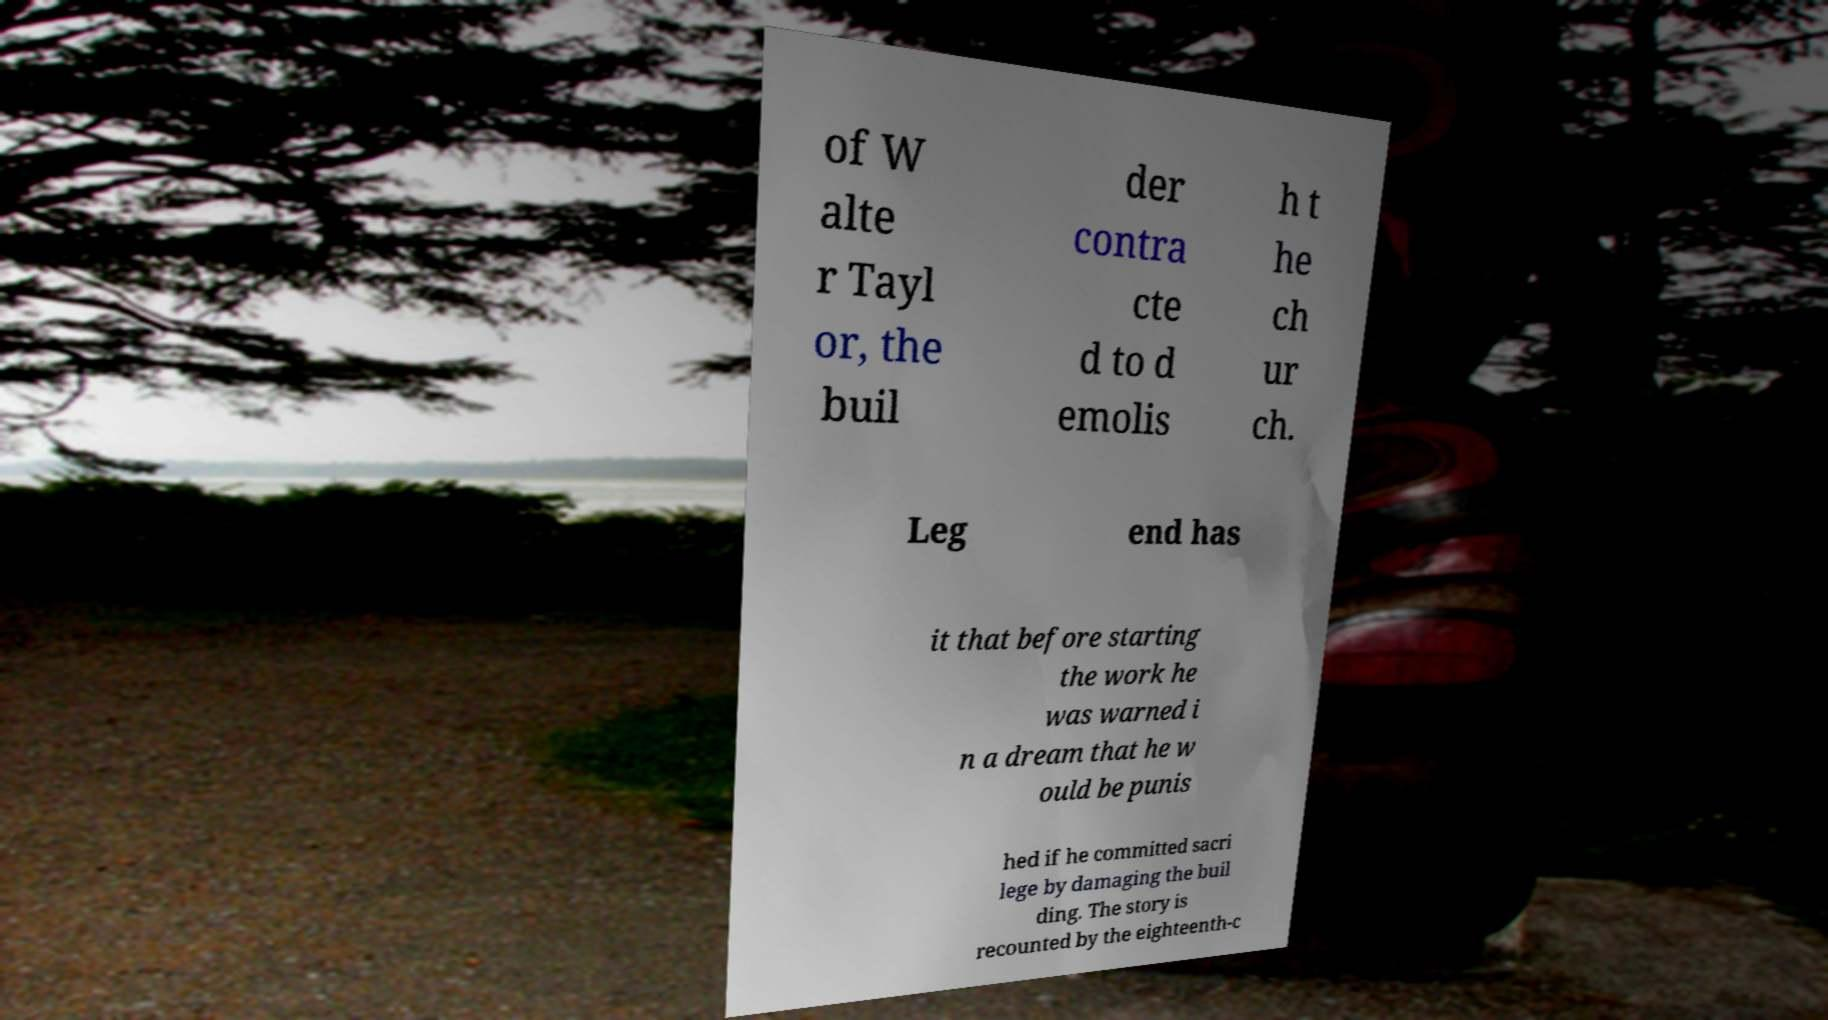What messages or text are displayed in this image? I need them in a readable, typed format. of W alte r Tayl or, the buil der contra cte d to d emolis h t he ch ur ch. Leg end has it that before starting the work he was warned i n a dream that he w ould be punis hed if he committed sacri lege by damaging the buil ding. The story is recounted by the eighteenth-c 